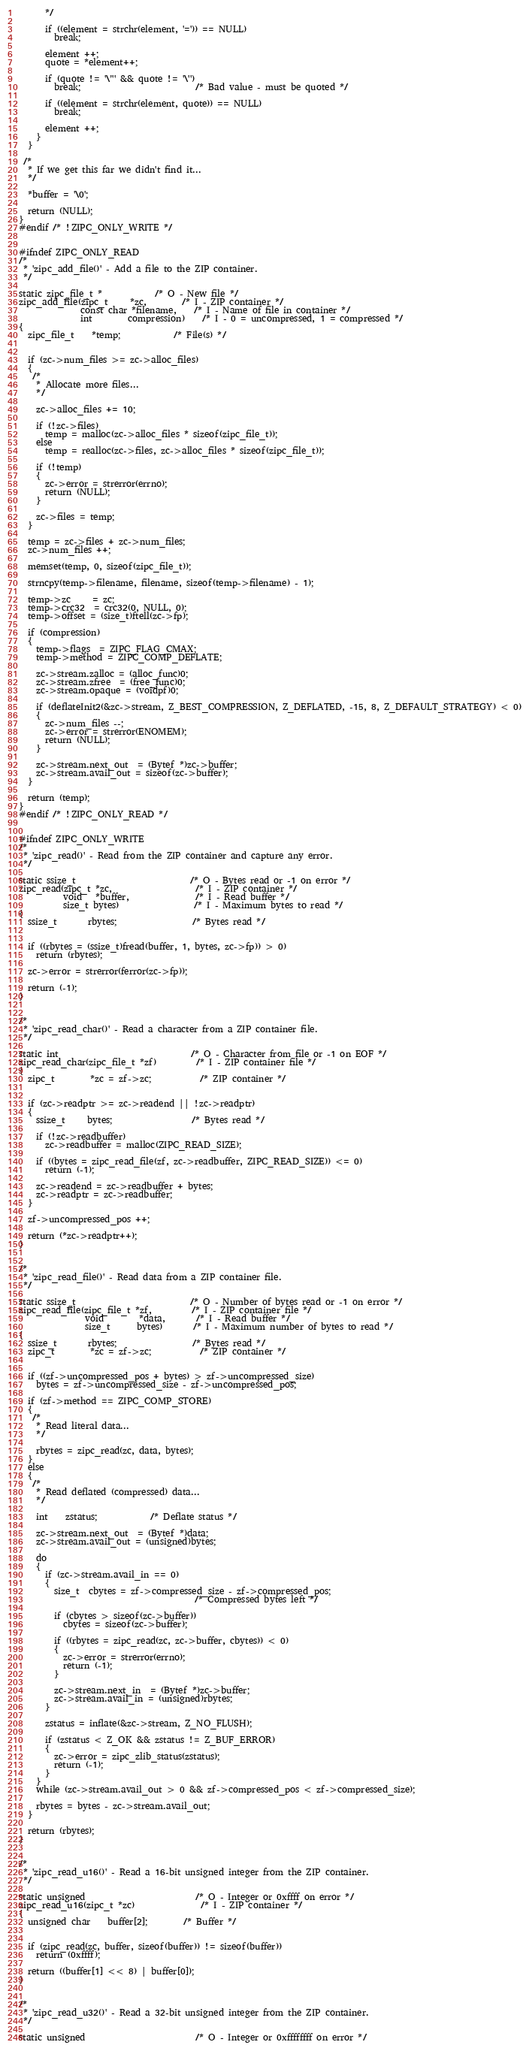Convert code to text. <code><loc_0><loc_0><loc_500><loc_500><_C_>      */

      if ((element = strchr(element, '=')) == NULL)
        break;

      element ++;
      quote = *element++;

      if (quote != '\"' && quote != '\'')
        break;                          /* Bad value - must be quoted */

      if ((element = strchr(element, quote)) == NULL)
        break;

      element ++;
    }
  }

 /*
  * If we get this far we didn't find it...
  */

  *buffer = '\0';

  return (NULL);
}
#endif /* !ZIPC_ONLY_WRITE */


#ifndef ZIPC_ONLY_READ
/*
 * 'zipc_add_file()' - Add a file to the ZIP container.
 */

static zipc_file_t *			/* O - New file */
zipc_add_file(zipc_t     *zc,		/* I - ZIP container */
              const char *filename,	/* I - Name of file in container */
              int        compression)	/* I - 0 = uncompressed, 1 = compressed */
{
  zipc_file_t	*temp;			/* File(s) */


  if (zc->num_files >= zc->alloc_files)
  {
   /*
    * Allocate more files...
    */

    zc->alloc_files += 10;

    if (!zc->files)
      temp = malloc(zc->alloc_files * sizeof(zipc_file_t));
    else
      temp = realloc(zc->files, zc->alloc_files * sizeof(zipc_file_t));

    if (!temp)
    {
      zc->error = strerror(errno);
      return (NULL);
    }

    zc->files = temp;
  }

  temp = zc->files + zc->num_files;
  zc->num_files ++;

  memset(temp, 0, sizeof(zipc_file_t));

  strncpy(temp->filename, filename, sizeof(temp->filename) - 1);

  temp->zc     = zc;
  temp->crc32  = crc32(0, NULL, 0);
  temp->offset = (size_t)ftell(zc->fp);

  if (compression)
  {
    temp->flags  = ZIPC_FLAG_CMAX;
    temp->method = ZIPC_COMP_DEFLATE;

    zc->stream.zalloc = (alloc_func)0;
    zc->stream.zfree  = (free_func)0;
    zc->stream.opaque = (voidpf)0;

    if (deflateInit2(&zc->stream, Z_BEST_COMPRESSION, Z_DEFLATED, -15, 8, Z_DEFAULT_STRATEGY) < 0)
    {
      zc->num_files --;
      zc->error = strerror(ENOMEM);
      return (NULL);
    }

    zc->stream.next_out  = (Bytef *)zc->buffer;
    zc->stream.avail_out = sizeof(zc->buffer);
  }

  return (temp);
}
#endif /* !ZIPC_ONLY_READ */


#ifndef ZIPC_ONLY_WRITE
/*
 * 'zipc_read()' - Read from the ZIP container and capture any error.
 */

static ssize_t                          /* O - Bytes read or -1 on error */
zipc_read(zipc_t *zc,                   /* I - ZIP container */
          void   *buffer,               /* I - Read buffer */
          size_t bytes)                 /* I - Maximum bytes to read */
{
  ssize_t       rbytes;                 /* Bytes read */


  if ((rbytes = (ssize_t)fread(buffer, 1, bytes, zc->fp)) > 0)
    return (rbytes);

  zc->error = strerror(ferror(zc->fp));

  return (-1);
}


/*
 * 'zipc_read_char()' - Read a character from a ZIP container file.
 */

static int                              /* O - Character from file or -1 on EOF */
zipc_read_char(zipc_file_t *zf)         /* I - ZIP container file */
{
  zipc_t        *zc = zf->zc;           /* ZIP container */


  if (zc->readptr >= zc->readend || !zc->readptr)
  {
    ssize_t     bytes;                  /* Bytes read */

    if (!zc->readbuffer)
      zc->readbuffer = malloc(ZIPC_READ_SIZE);

    if ((bytes = zipc_read_file(zf, zc->readbuffer, ZIPC_READ_SIZE)) <= 0)
      return (-1);

    zc->readend = zc->readbuffer + bytes;
    zc->readptr = zc->readbuffer;
  }

  zf->uncompressed_pos ++;

  return (*zc->readptr++);
}


/*
 * 'zipc_read_file()' - Read data from a ZIP container file.
 */

static ssize_t                          /* O - Number of bytes read or -1 on error */
zipc_read_file(zipc_file_t *zf,         /* I - ZIP container file */
               void        *data,       /* I - Read buffer */
               size_t      bytes)       /* I - Maximum number of bytes to read */
{
  ssize_t       rbytes;                 /* Bytes read */
  zipc_t        *zc = zf->zc;           /* ZIP container */


  if ((zf->uncompressed_pos + bytes) > zf->uncompressed_size)
    bytes = zf->uncompressed_size - zf->uncompressed_pos;

  if (zf->method == ZIPC_COMP_STORE)
  {
   /*
    * Read literal data...
    */

    rbytes = zipc_read(zc, data, bytes);
  }
  else
  {
   /*
    * Read deflated (compressed) data...
    */

    int	zstatus;			/* Deflate status */

    zc->stream.next_out  = (Bytef *)data;
    zc->stream.avail_out = (unsigned)bytes;

    do
    {
      if (zc->stream.avail_in == 0)
      {
        size_t  cbytes = zf->compressed_size - zf->compressed_pos;
                                        /* Compressed bytes left */

        if (cbytes > sizeof(zc->buffer))
          cbytes = sizeof(zc->buffer);

        if ((rbytes = zipc_read(zc, zc->buffer, cbytes)) < 0)
        {
          zc->error = strerror(errno);
          return (-1);
        }

        zc->stream.next_in  = (Bytef *)zc->buffer;
        zc->stream.avail_in = (unsigned)rbytes;
      }

      zstatus = inflate(&zc->stream, Z_NO_FLUSH);

      if (zstatus < Z_OK && zstatus != Z_BUF_ERROR)
      {
        zc->error = zipc_zlib_status(zstatus);
        return (-1);
      }
    }
    while (zc->stream.avail_out > 0 && zf->compressed_pos < zf->compressed_size);

    rbytes = bytes - zc->stream.avail_out;
  }

  return (rbytes);
}


/*
 * 'zipc_read_u16()' - Read a 16-bit unsigned integer from the ZIP container.
 */

static unsigned                         /* O - Integer or 0xffff on error */
zipc_read_u16(zipc_t *zc)               /* I - ZIP container */
{
  unsigned char	buffer[2];		/* Buffer */


  if (zipc_read(zc, buffer, sizeof(buffer)) != sizeof(buffer))
    return (0xffff);

  return ((buffer[1] << 8) | buffer[0]);
}


/*
 * 'zipc_read_u32()' - Read a 32-bit unsigned integer from the ZIP container.
 */

static unsigned                         /* O - Integer or 0xffffffff on error */</code> 